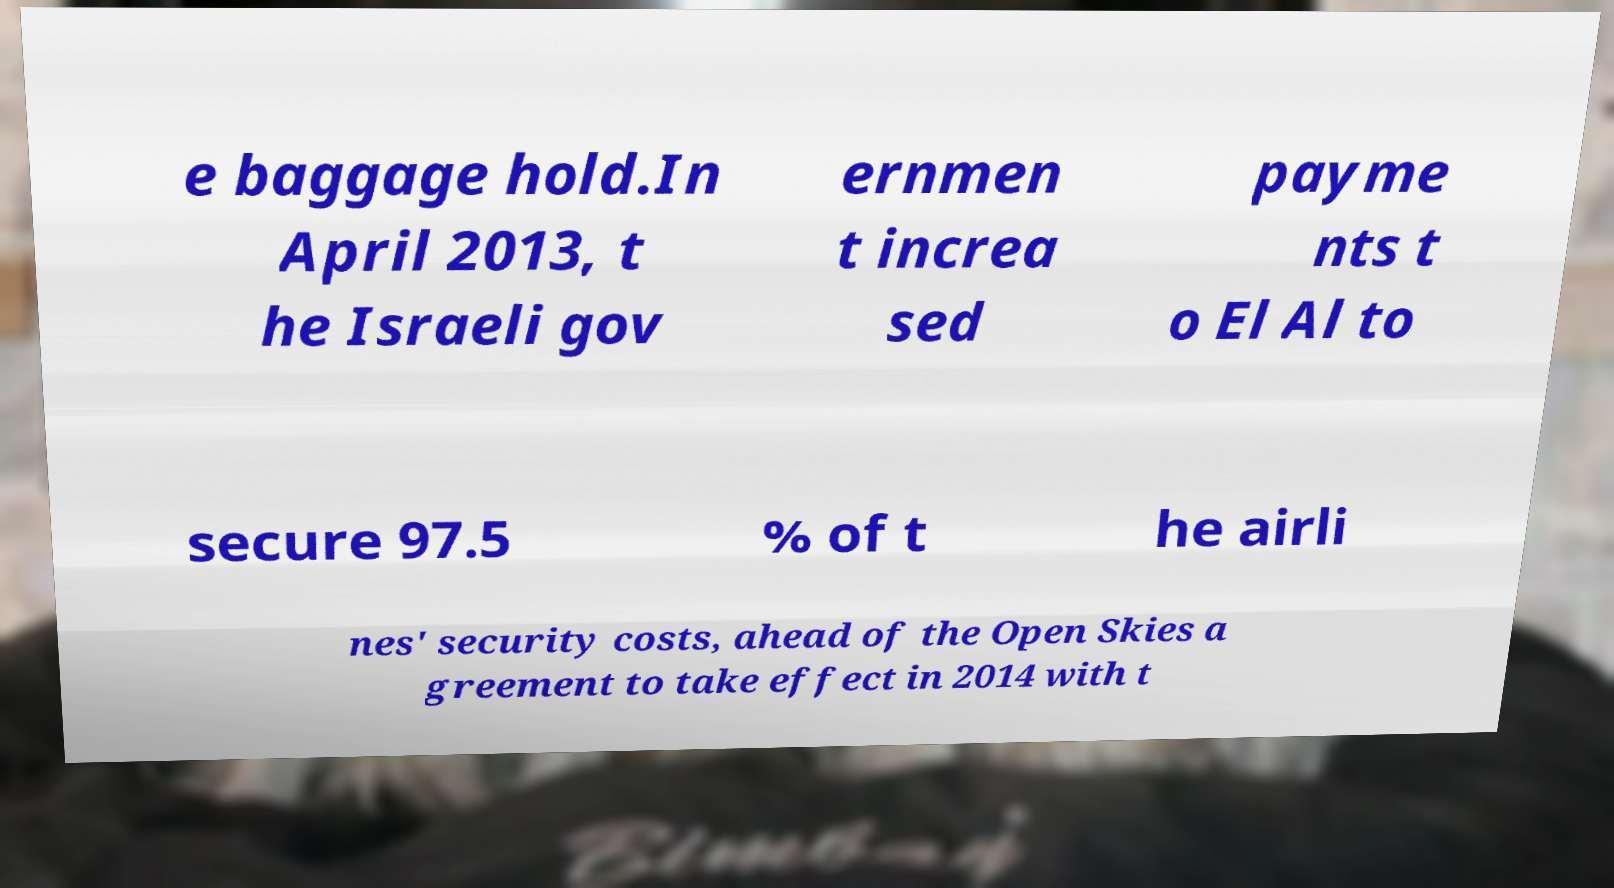Could you extract and type out the text from this image? e baggage hold.In April 2013, t he Israeli gov ernmen t increa sed payme nts t o El Al to secure 97.5 % of t he airli nes' security costs, ahead of the Open Skies a greement to take effect in 2014 with t 